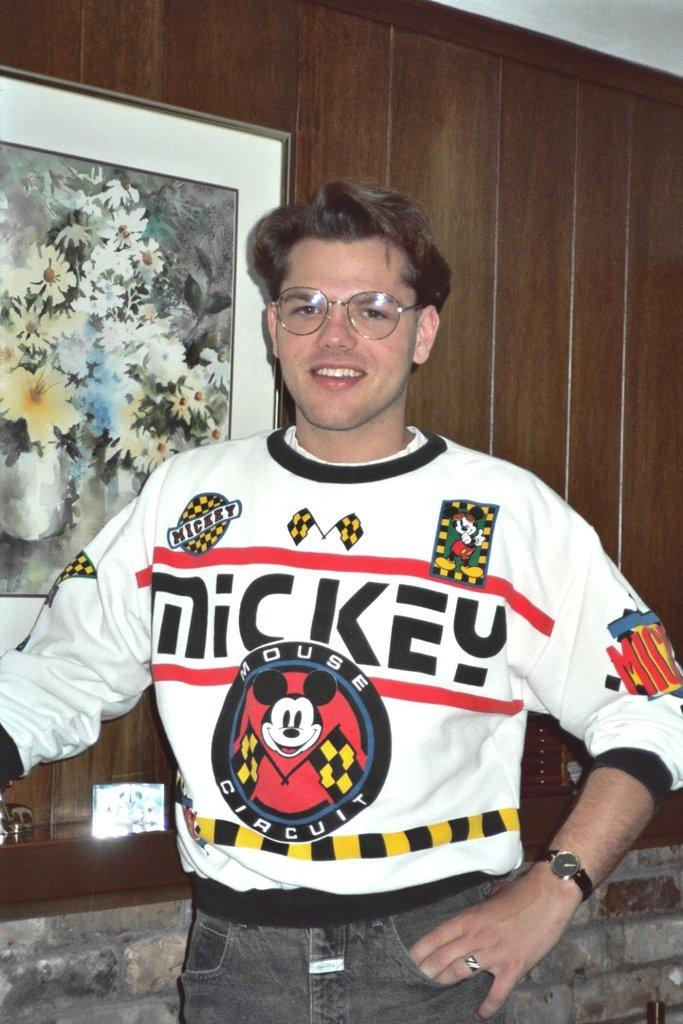<image>
Write a terse but informative summary of the picture. A young man wearing glasses wears a Mickey House Circuit sweatshirt. 